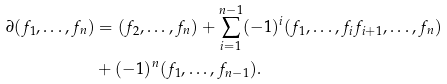Convert formula to latex. <formula><loc_0><loc_0><loc_500><loc_500>\partial ( f _ { 1 } , \dots , f _ { n } ) & = ( f _ { 2 } , \dots , f _ { n } ) + \sum _ { i = 1 } ^ { n - 1 } ( - 1 ) ^ { i } ( f _ { 1 } , \dots , f _ { i } f _ { i + 1 } , \dots , f _ { n } ) \\ & + ( - 1 ) ^ { n } ( f _ { 1 } , \dots , f _ { n - 1 } ) .</formula> 